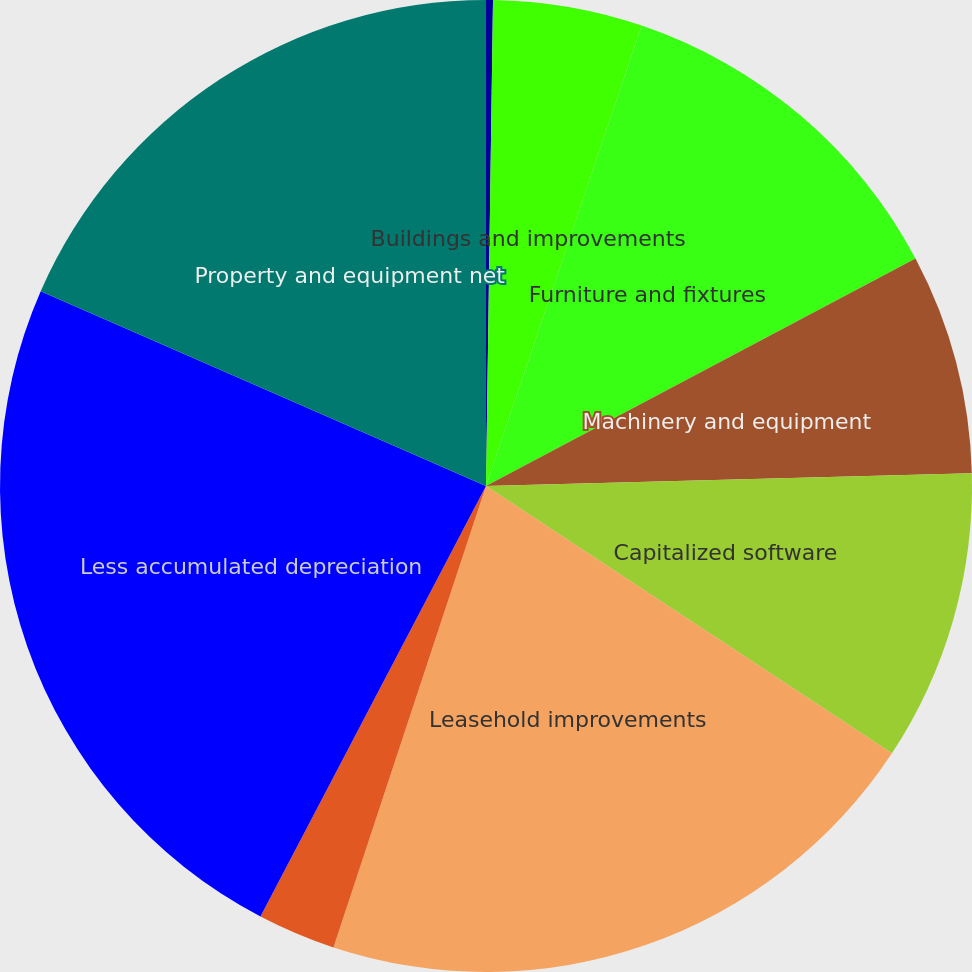Convert chart to OTSL. <chart><loc_0><loc_0><loc_500><loc_500><pie_chart><fcel>Land and improvements<fcel>Buildings and improvements<fcel>Furniture and fixtures<fcel>Machinery and equipment<fcel>Capitalized software<fcel>Leasehold improvements<fcel>Construction in progress<fcel>Less accumulated depreciation<fcel>Property and equipment net<nl><fcel>0.23%<fcel>4.96%<fcel>12.06%<fcel>7.33%<fcel>9.69%<fcel>20.81%<fcel>2.6%<fcel>23.88%<fcel>18.44%<nl></chart> 